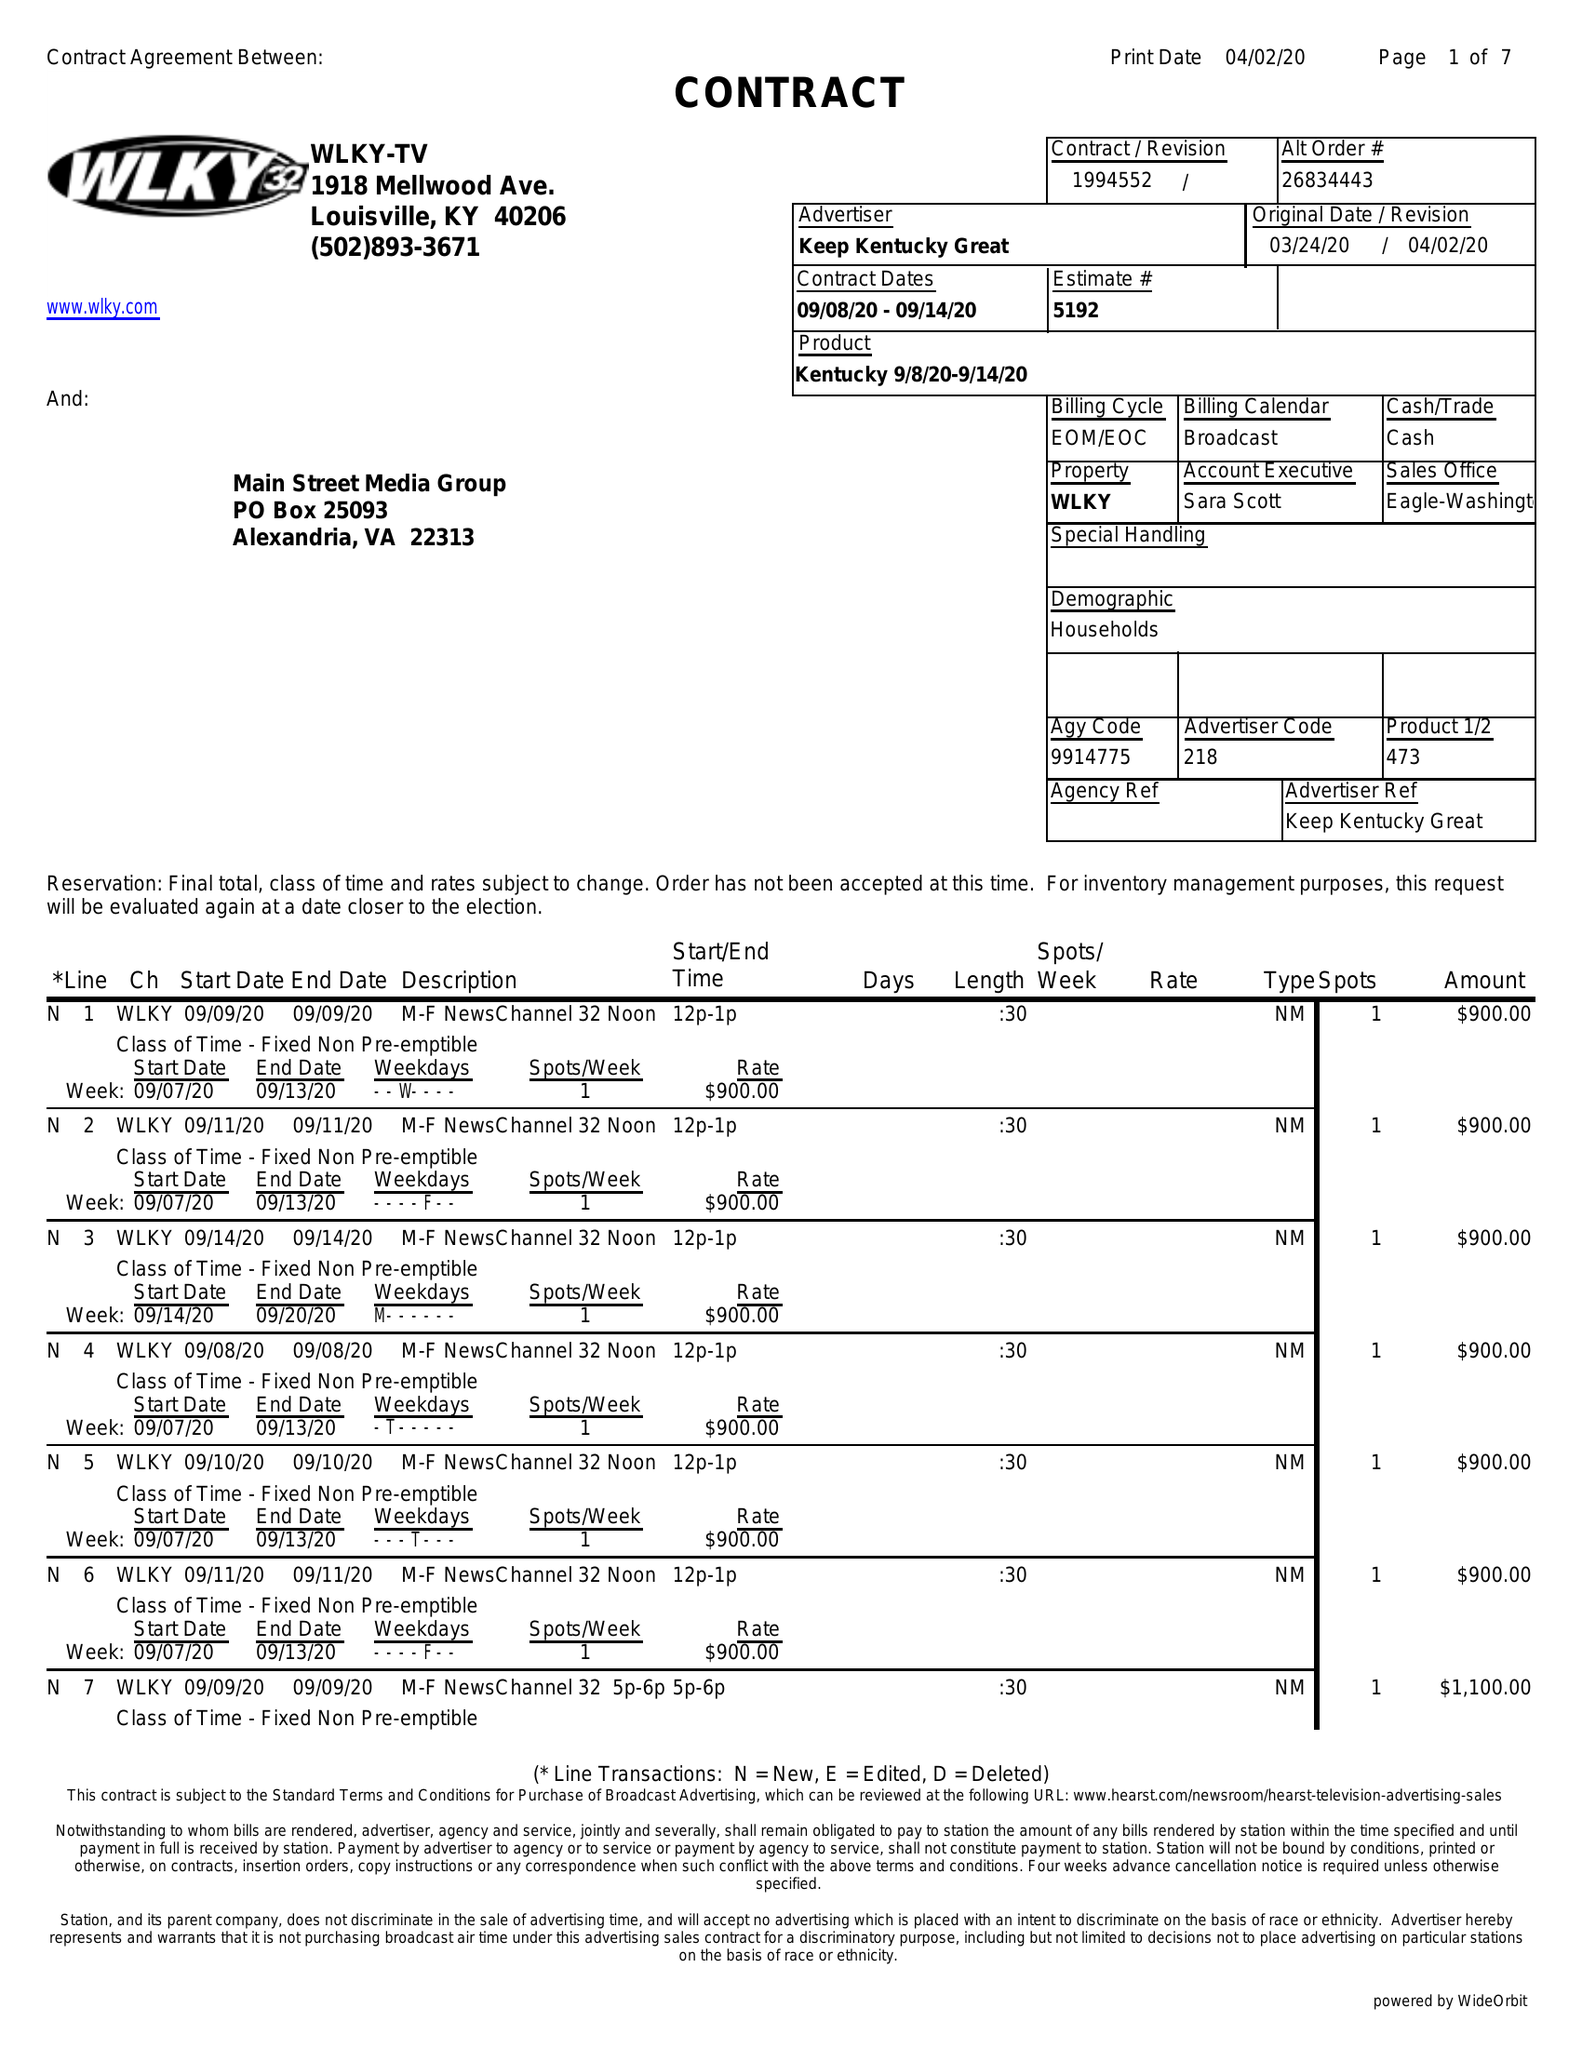What is the value for the flight_from?
Answer the question using a single word or phrase. 09/08/20 